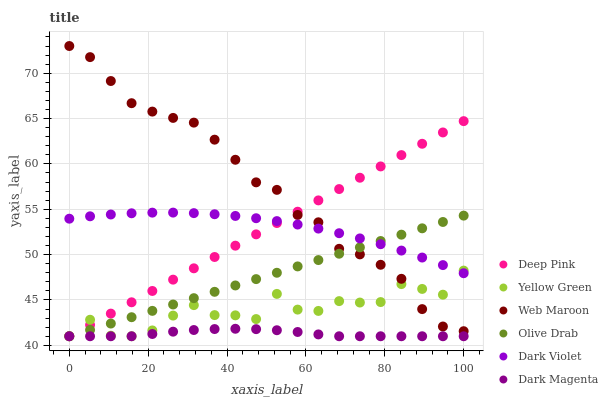Does Dark Magenta have the minimum area under the curve?
Answer yes or no. Yes. Does Web Maroon have the maximum area under the curve?
Answer yes or no. Yes. Does Yellow Green have the minimum area under the curve?
Answer yes or no. No. Does Yellow Green have the maximum area under the curve?
Answer yes or no. No. Is Deep Pink the smoothest?
Answer yes or no. Yes. Is Yellow Green the roughest?
Answer yes or no. Yes. Is Web Maroon the smoothest?
Answer yes or no. No. Is Web Maroon the roughest?
Answer yes or no. No. Does Deep Pink have the lowest value?
Answer yes or no. Yes. Does Web Maroon have the lowest value?
Answer yes or no. No. Does Web Maroon have the highest value?
Answer yes or no. Yes. Does Yellow Green have the highest value?
Answer yes or no. No. Is Dark Magenta less than Web Maroon?
Answer yes or no. Yes. Is Web Maroon greater than Dark Magenta?
Answer yes or no. Yes. Does Olive Drab intersect Dark Violet?
Answer yes or no. Yes. Is Olive Drab less than Dark Violet?
Answer yes or no. No. Is Olive Drab greater than Dark Violet?
Answer yes or no. No. Does Dark Magenta intersect Web Maroon?
Answer yes or no. No. 